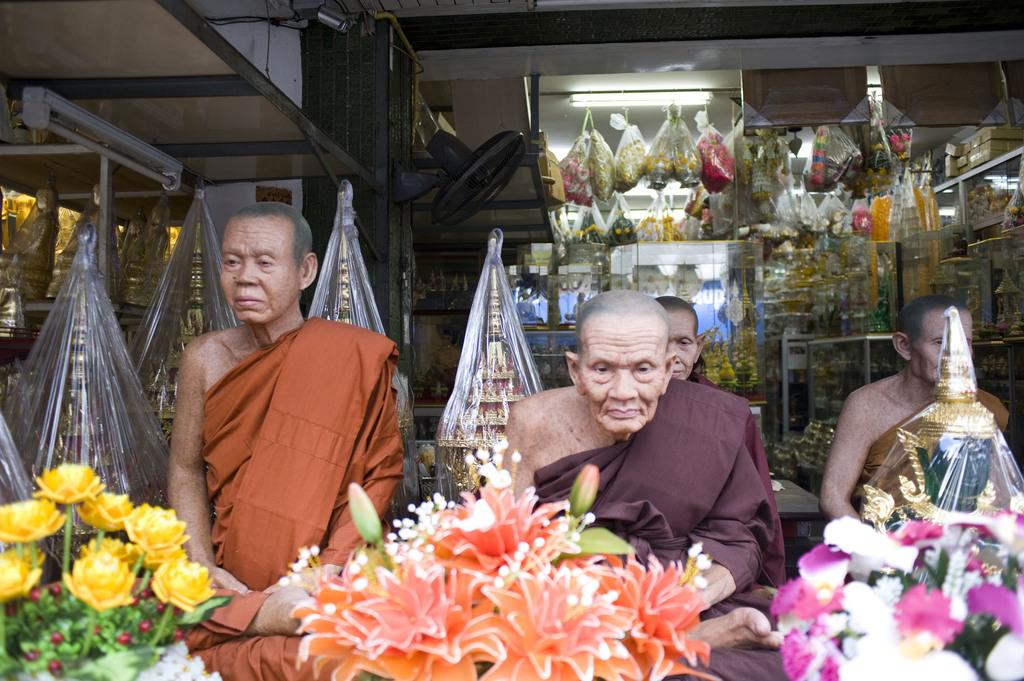What type of establishment is depicted in the image? There is a store in the image. How many men are standing on the floor in the image? There are four men standing on the floor in the image. What type of tin can be seen in the image? There is no tin present in the image. What type of food is being prepared or served in the image? The provided facts do not mention any food being prepared or served in the image. 